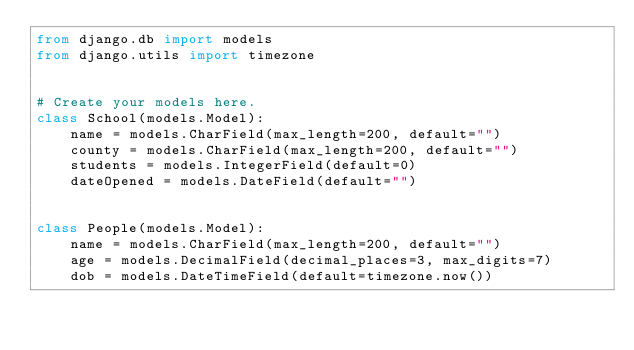Convert code to text. <code><loc_0><loc_0><loc_500><loc_500><_Python_>from django.db import models
from django.utils import timezone


# Create your models here.
class School(models.Model):
    name = models.CharField(max_length=200, default="")
    county = models.CharField(max_length=200, default="")
    students = models.IntegerField(default=0)
    dateOpened = models.DateField(default="")


class People(models.Model):
    name = models.CharField(max_length=200, default="")
    age = models.DecimalField(decimal_places=3, max_digits=7)
    dob = models.DateTimeField(default=timezone.now())</code> 